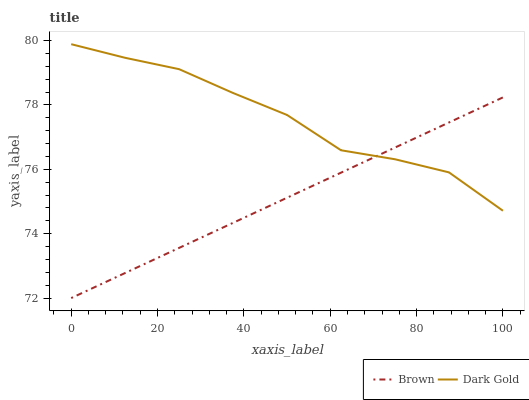Does Brown have the minimum area under the curve?
Answer yes or no. Yes. Does Dark Gold have the maximum area under the curve?
Answer yes or no. Yes. Does Dark Gold have the minimum area under the curve?
Answer yes or no. No. Is Brown the smoothest?
Answer yes or no. Yes. Is Dark Gold the roughest?
Answer yes or no. Yes. Is Dark Gold the smoothest?
Answer yes or no. No. Does Brown have the lowest value?
Answer yes or no. Yes. Does Dark Gold have the lowest value?
Answer yes or no. No. Does Dark Gold have the highest value?
Answer yes or no. Yes. Does Brown intersect Dark Gold?
Answer yes or no. Yes. Is Brown less than Dark Gold?
Answer yes or no. No. Is Brown greater than Dark Gold?
Answer yes or no. No. 